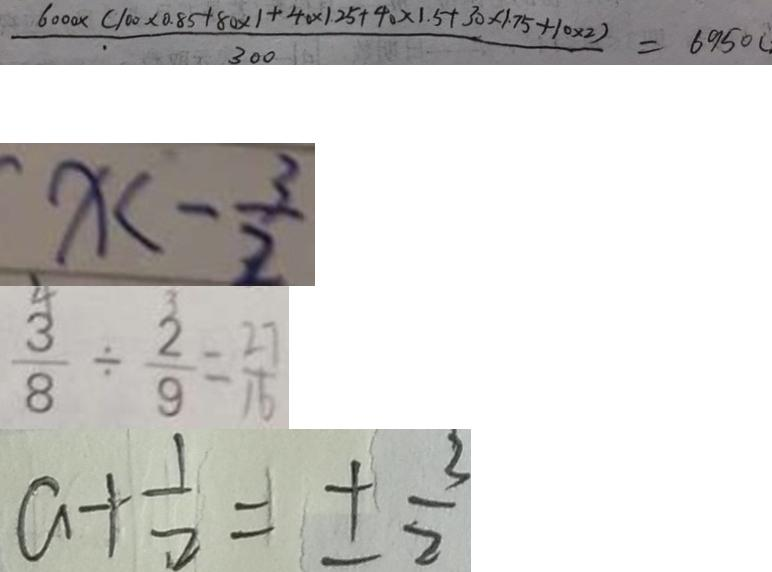Convert formula to latex. <formula><loc_0><loc_0><loc_500><loc_500>\frac { 6 0 0 0 \times ( 1 0 0 \times 0 . 8 5 + 8 0 \times 1 + 4 0 \times 1 . 2 5 + 4 0 \times 1 . 5 + 3 0 \times 1 . 7 5 + 1 0 \times 2 ) } { 3 0 0 } = 6 9 5 0 ( 
 x < - \frac { 3 } { 2 } 
 \frac { 3 } { 8 } \div \frac { 2 } { 9 } = \frac { 2 7 } { 1 6 } 
 a + \frac { 1 } { 2 } = \pm \frac { 3 } { 2 }</formula> 